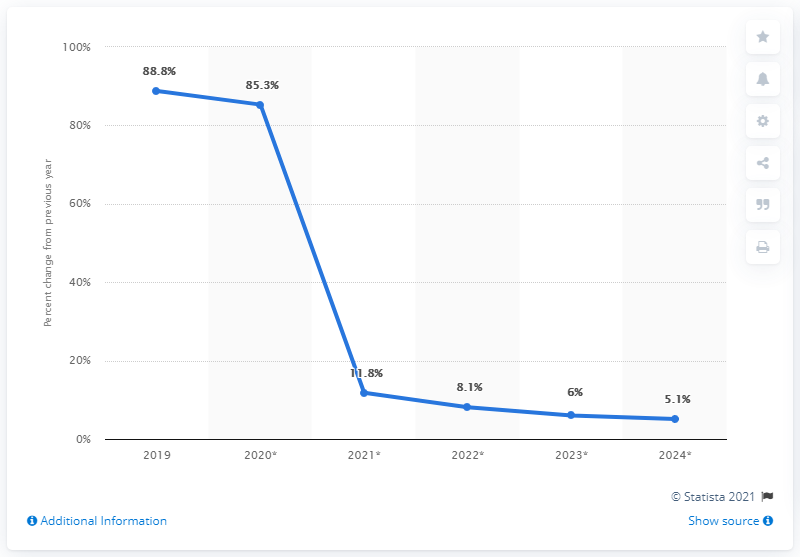Point out several critical features in this image. In 2020, TikTok observed a substantial increase in its user base in the United States, with a growth of 85.3%. 